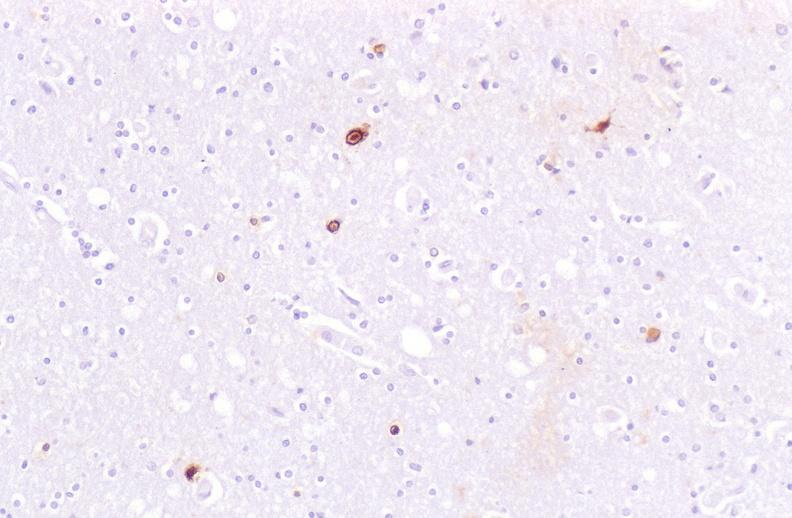does this image show brain, herpes simplex virus immunohistochemistry?
Answer the question using a single word or phrase. Yes 